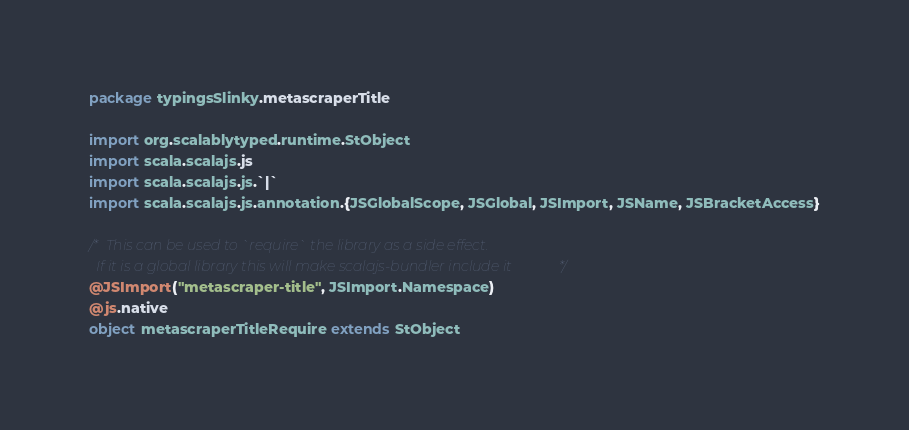Convert code to text. <code><loc_0><loc_0><loc_500><loc_500><_Scala_>package typingsSlinky.metascraperTitle

import org.scalablytyped.runtime.StObject
import scala.scalajs.js
import scala.scalajs.js.`|`
import scala.scalajs.js.annotation.{JSGlobalScope, JSGlobal, JSImport, JSName, JSBracketAccess}

/* This can be used to `require` the library as a side effect.
  If it is a global library this will make scalajs-bundler include it */
@JSImport("metascraper-title", JSImport.Namespace)
@js.native
object metascraperTitleRequire extends StObject
</code> 